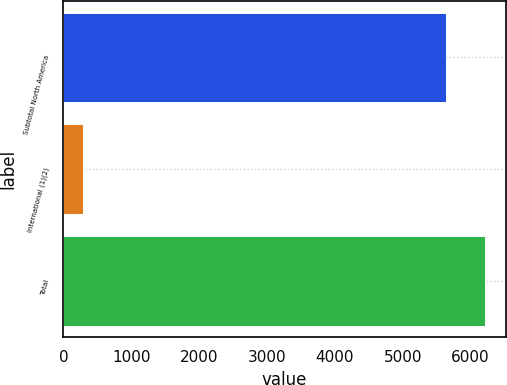Convert chart to OTSL. <chart><loc_0><loc_0><loc_500><loc_500><bar_chart><fcel>Subtotal North America<fcel>International (1)(2)<fcel>Total<nl><fcel>5643<fcel>291<fcel>6207.3<nl></chart> 